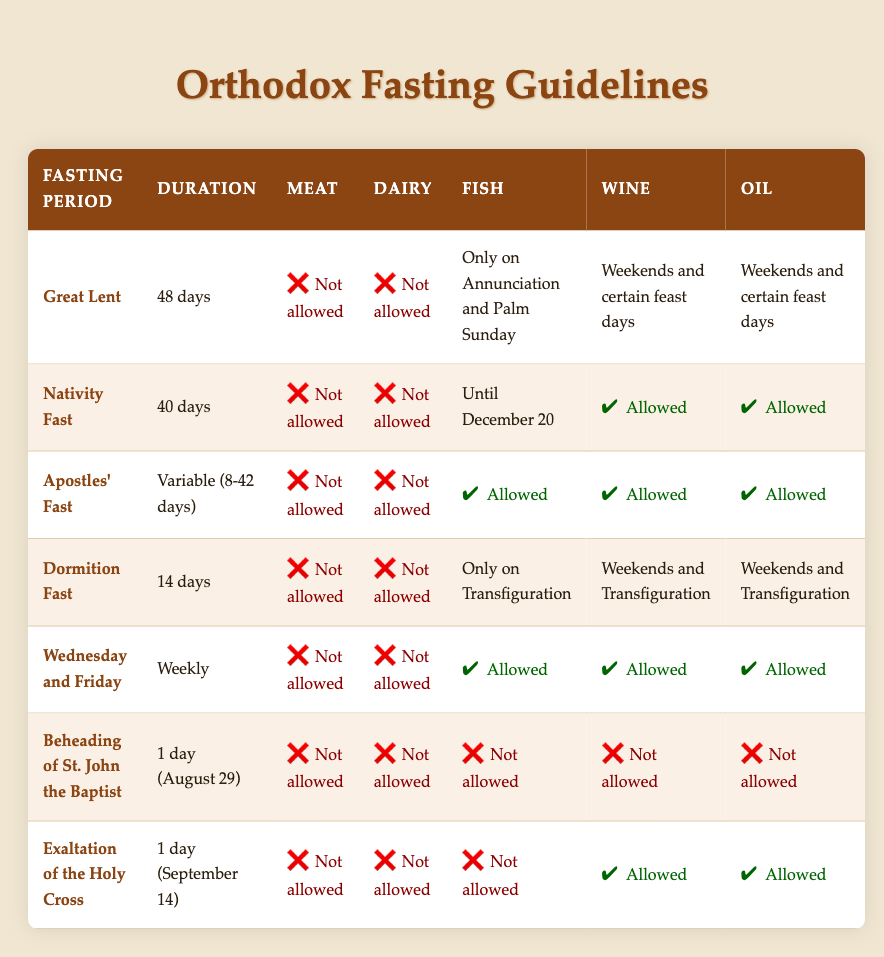What is the duration of Great Lent? The table lists the fasting periods along with their durations. Under the "Great Lent" row, the associated duration is stated as "48 days."
Answer: 48 days Are fish allowed during the Nativity Fast? The table indicates that fish is allowed only until December 20 under the row for "Nativity Fast." Therefore, the answer is yes, fish is allowed until that date.
Answer: Yes For which fasting period is oil not allowed? By examining the table, we see that for both the "Beheading of St. John the Baptist" and "Exaltation of the Holy Cross," oil is not allowed as indicated in their respective rows. Thus, these two periods meet the criteria.
Answer: Beheading of St. John the Baptist and Exaltation of the Holy Cross What is the average duration of the fasting periods listed? First, we will total the durations: 48 days (Great Lent) + 40 days (Nativity Fast) + (8 to 42 days for Apostles' Fast, so we can take the average of 8 and 42, which is 25 days) + 14 days (Dormition Fast) + 7 days (Wednesday and Friday, weekly) + 1 day (Beheading of St. John the Baptist) + 1 day (Exaltation of the Holy Cross). That results in the sum total being 48 + 40 + 25 + 14 + 7 + 1 + 1 = 136 days. There are 7 periods in total, so the average duration is then 136 days divided by 7, which equals approximately 19.43 days.
Answer: Approximately 19.43 days Is wine allowed during the Dormition Fast? Upon reviewing the "Dormition Fast" row, it states that wine is allowed on weekends and Transfiguration, indicating that it is conditionally allowed rather than outright prohibited. Therefore, the statement can be categorized as true.
Answer: Yes Which fasting period prohibits fish the most strictly? The table shows that "Beheading of St. John the Baptist" prohibits fish completely, as indicated by the "not allowed" label. Other periods have varying rules for fish, such as only allowing it on special days or certain conditions. Thus, this is the strictest prohibition.
Answer: Beheading of St. John the Baptist How many fasting periods allow dairy? Reviewing the table, dairy is allowed only during the "Nativity Fast," the "Apostles' Fast," and the "Wednesday and Friday" periods. Counting these gives us three periods in total where dairy is allowed.
Answer: 3 Which fasting period has the longest duration? A review of the durations shows "Great Lent" at 48 days is the longest compared to any other fasting period listed. No other period exceeds this duration.
Answer: Great Lent 